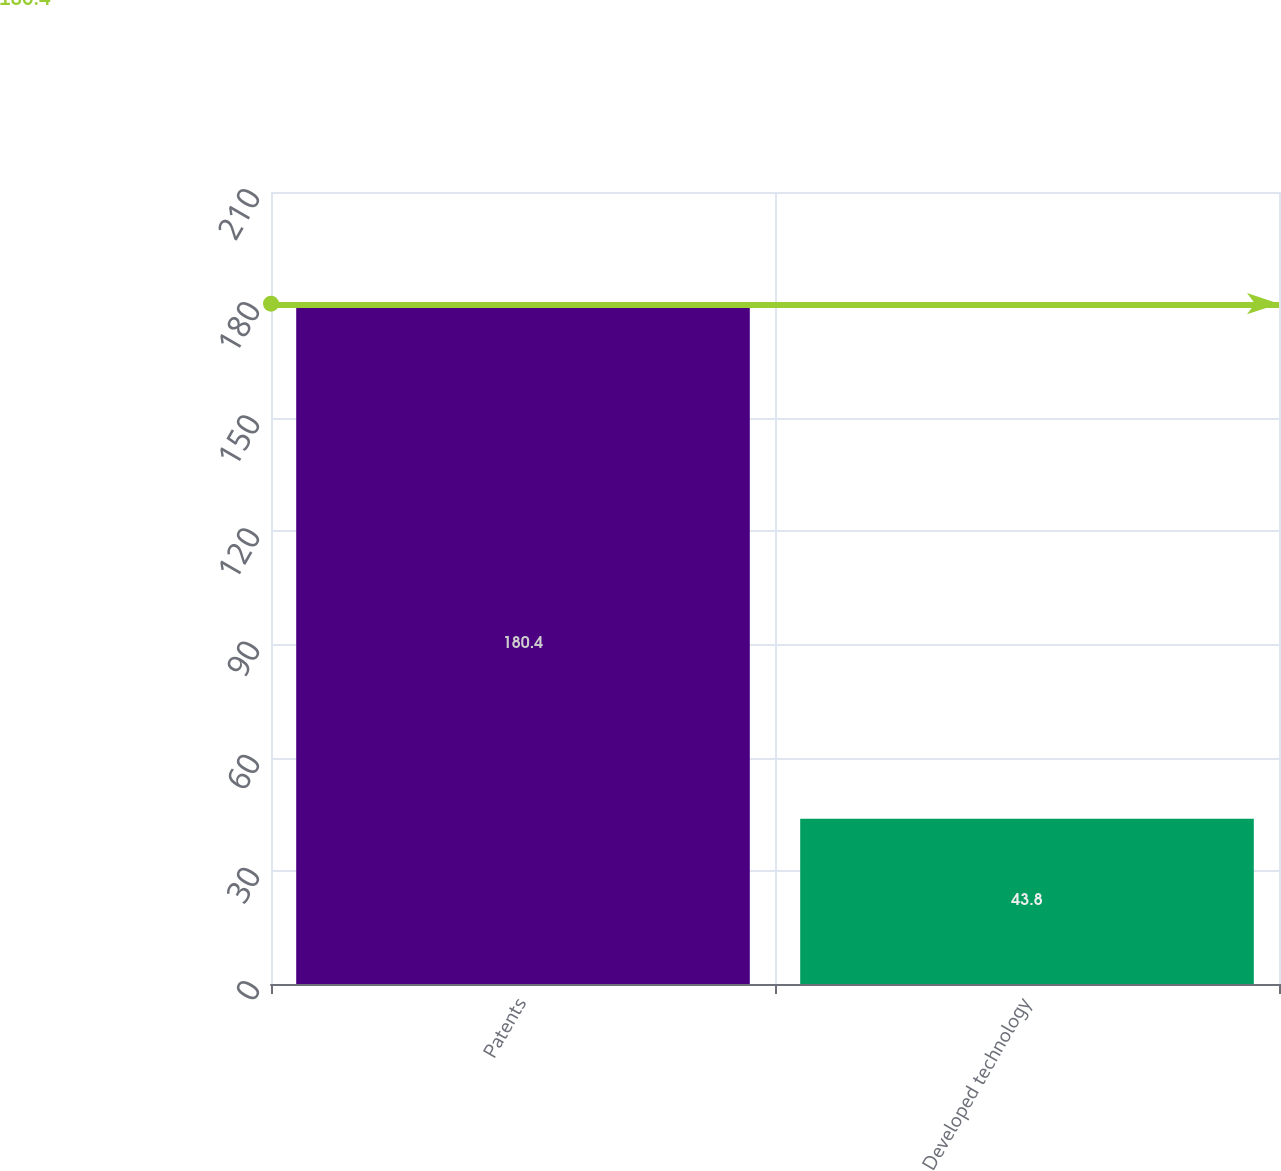Convert chart to OTSL. <chart><loc_0><loc_0><loc_500><loc_500><bar_chart><fcel>Patents<fcel>Developed technology<nl><fcel>180.4<fcel>43.8<nl></chart> 